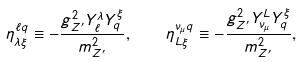<formula> <loc_0><loc_0><loc_500><loc_500>\eta _ { \lambda \xi } ^ { \ell q } \equiv - \frac { g _ { Z ^ { \prime } } ^ { 2 } Y _ { \ell } ^ { \lambda } Y _ { q } ^ { \xi } } { m _ { Z ^ { \prime } } ^ { 2 } } , \quad \eta _ { L \xi } ^ { \nu _ { \mu } q } \equiv - \frac { g _ { Z ^ { \prime } } ^ { 2 } Y _ { \nu _ { \mu } } ^ { L } Y _ { q } ^ { \xi } } { m _ { Z ^ { \prime } } ^ { 2 } } ,</formula> 